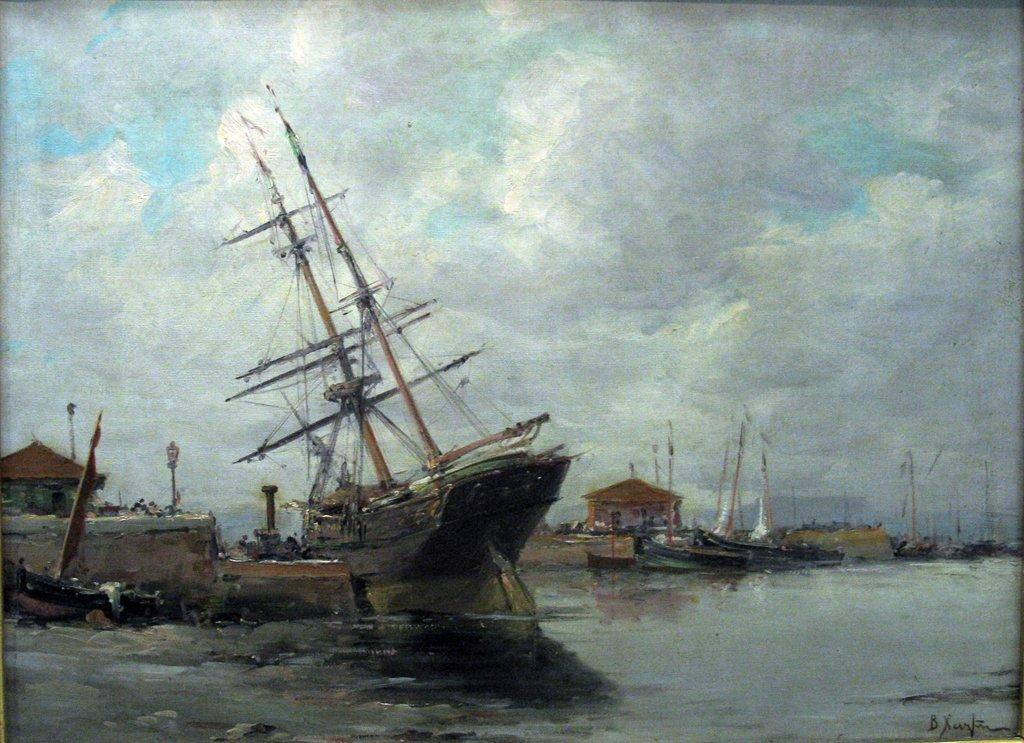What is the main subject of the painting? The painting depicts a water surface. What objects are on the water surface? There are boats with poles in the painting. Are the boats connected to anything? Yes, there are wires connected to the boats. What can be seen in the background of the painting? The sky is visible in the background of the painting. What is the condition of the sky in the painting? Clouds are present in the sky. How many cubs are playing with a hammer near the boats in the painting? There are no cubs or hammers present in the painting; it features a water surface with boats and wires. 